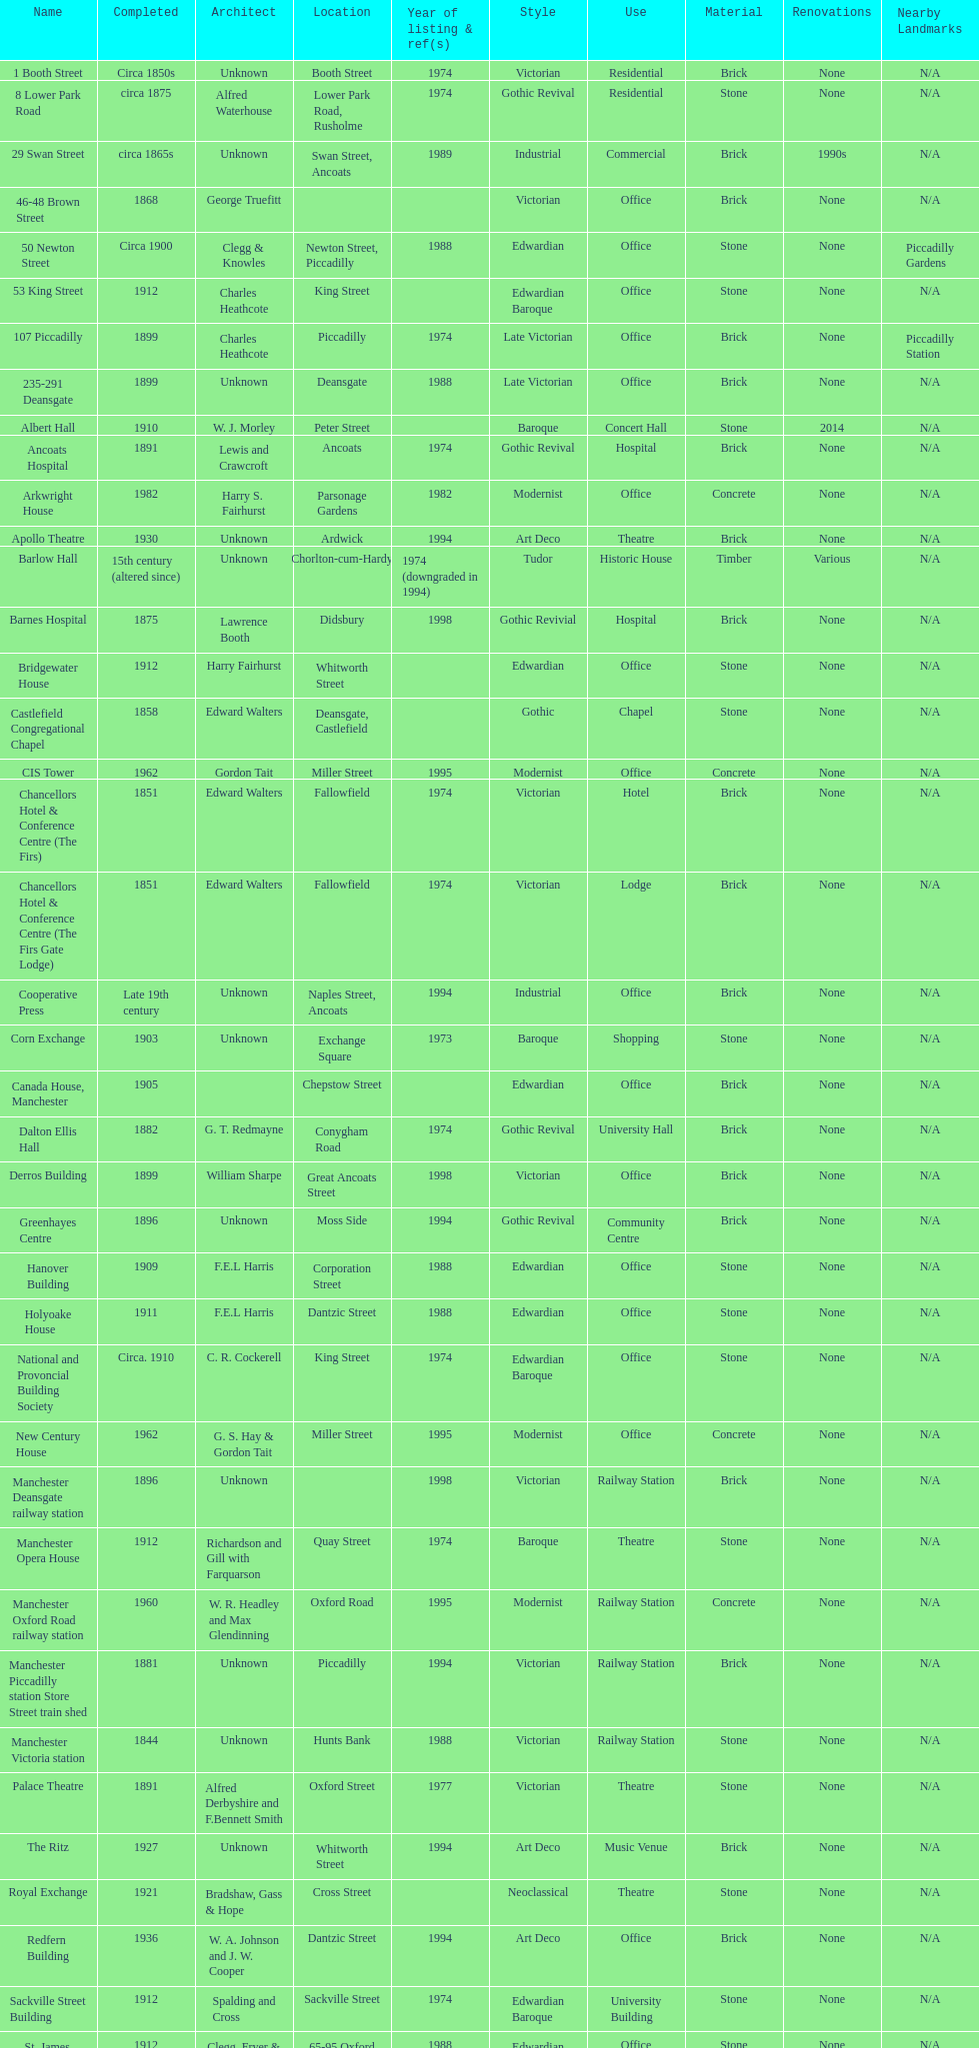What is the street of the only building listed in 1989? Swan Street. 